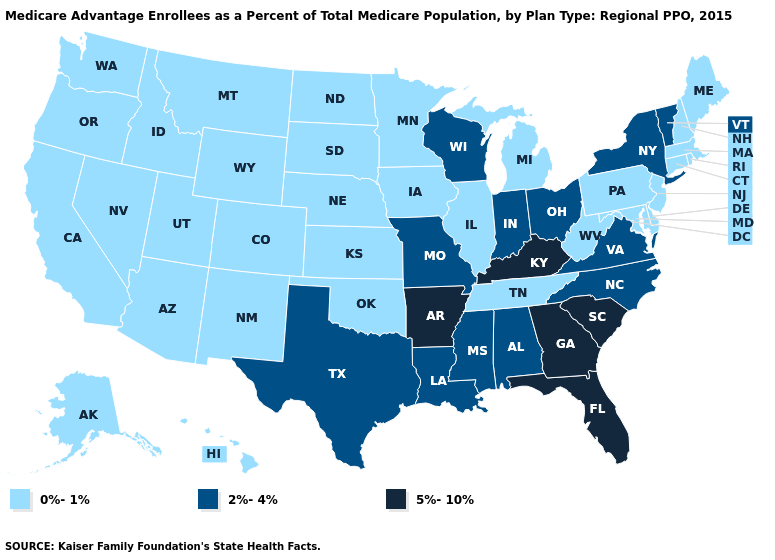Name the states that have a value in the range 0%-1%?
Concise answer only. Alaska, Arizona, California, Colorado, Connecticut, Delaware, Hawaii, Iowa, Idaho, Illinois, Kansas, Massachusetts, Maryland, Maine, Michigan, Minnesota, Montana, North Dakota, Nebraska, New Hampshire, New Jersey, New Mexico, Nevada, Oklahoma, Oregon, Pennsylvania, Rhode Island, South Dakota, Tennessee, Utah, Washington, West Virginia, Wyoming. What is the value of Colorado?
Keep it brief. 0%-1%. Name the states that have a value in the range 0%-1%?
Concise answer only. Alaska, Arizona, California, Colorado, Connecticut, Delaware, Hawaii, Iowa, Idaho, Illinois, Kansas, Massachusetts, Maryland, Maine, Michigan, Minnesota, Montana, North Dakota, Nebraska, New Hampshire, New Jersey, New Mexico, Nevada, Oklahoma, Oregon, Pennsylvania, Rhode Island, South Dakota, Tennessee, Utah, Washington, West Virginia, Wyoming. Name the states that have a value in the range 0%-1%?
Give a very brief answer. Alaska, Arizona, California, Colorado, Connecticut, Delaware, Hawaii, Iowa, Idaho, Illinois, Kansas, Massachusetts, Maryland, Maine, Michigan, Minnesota, Montana, North Dakota, Nebraska, New Hampshire, New Jersey, New Mexico, Nevada, Oklahoma, Oregon, Pennsylvania, Rhode Island, South Dakota, Tennessee, Utah, Washington, West Virginia, Wyoming. Among the states that border New Mexico , does Texas have the highest value?
Give a very brief answer. Yes. Name the states that have a value in the range 5%-10%?
Answer briefly. Arkansas, Florida, Georgia, Kentucky, South Carolina. What is the value of Maryland?
Be succinct. 0%-1%. Does the map have missing data?
Give a very brief answer. No. What is the value of Vermont?
Keep it brief. 2%-4%. Does New York have the lowest value in the Northeast?
Answer briefly. No. Does Rhode Island have the highest value in the USA?
Keep it brief. No. Does Nebraska have the highest value in the MidWest?
Answer briefly. No. Does Massachusetts have the same value as Georgia?
Short answer required. No. Does Georgia have the highest value in the South?
Be succinct. Yes. What is the highest value in the USA?
Concise answer only. 5%-10%. 